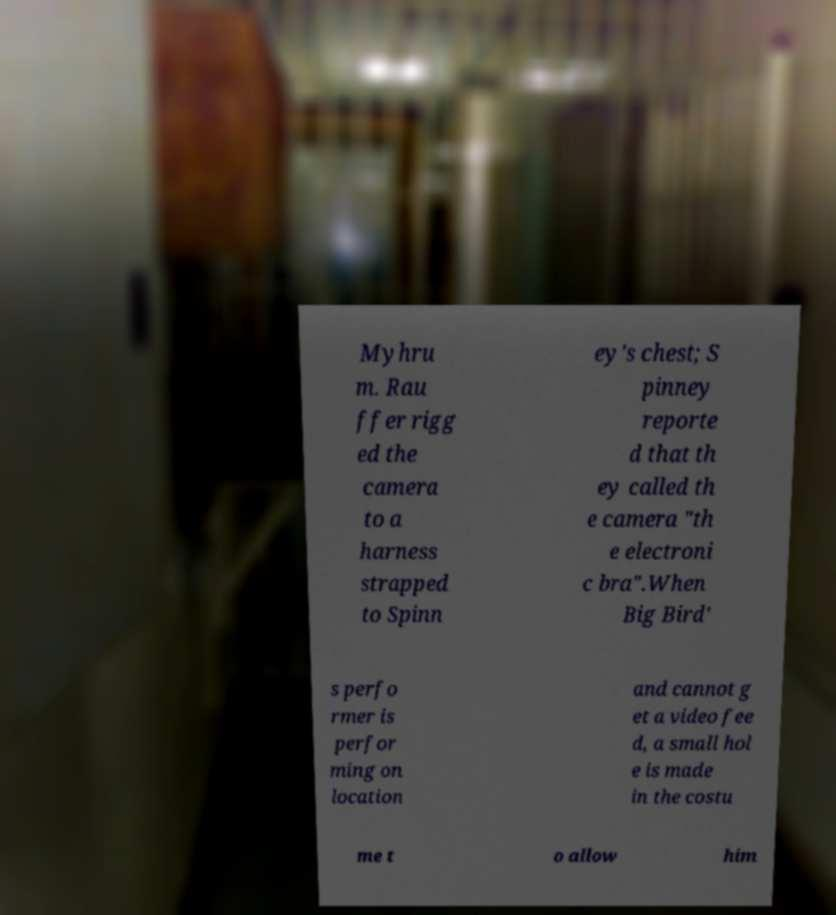There's text embedded in this image that I need extracted. Can you transcribe it verbatim? Myhru m. Rau ffer rigg ed the camera to a harness strapped to Spinn ey's chest; S pinney reporte d that th ey called th e camera "th e electroni c bra".When Big Bird' s perfo rmer is perfor ming on location and cannot g et a video fee d, a small hol e is made in the costu me t o allow him 